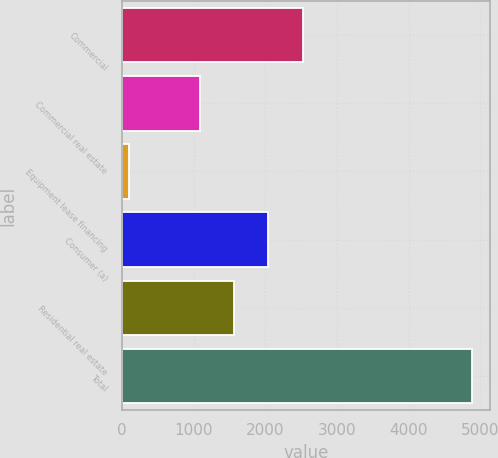<chart> <loc_0><loc_0><loc_500><loc_500><bar_chart><fcel>Commercial<fcel>Commercial real estate<fcel>Equipment lease financing<fcel>Consumer (a)<fcel>Residential real estate<fcel>Total<nl><fcel>2523.9<fcel>1086<fcel>94<fcel>2044.6<fcel>1565.3<fcel>4887<nl></chart> 